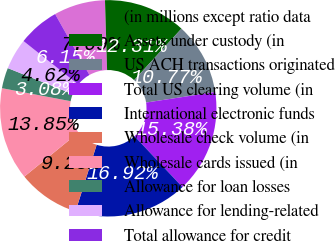Convert chart. <chart><loc_0><loc_0><loc_500><loc_500><pie_chart><fcel>(in millions except ratio data<fcel>Assets under custody (in<fcel>US ACH transactions originated<fcel>Total US clearing volume (in<fcel>International electronic funds<fcel>Wholesale check volume (in<fcel>Wholesale cards issued (in<fcel>Allowance for loan losses<fcel>Allowance for lending-related<fcel>Total allowance for credit<nl><fcel>7.69%<fcel>12.31%<fcel>10.77%<fcel>15.38%<fcel>16.92%<fcel>9.23%<fcel>13.85%<fcel>3.08%<fcel>4.62%<fcel>6.15%<nl></chart> 